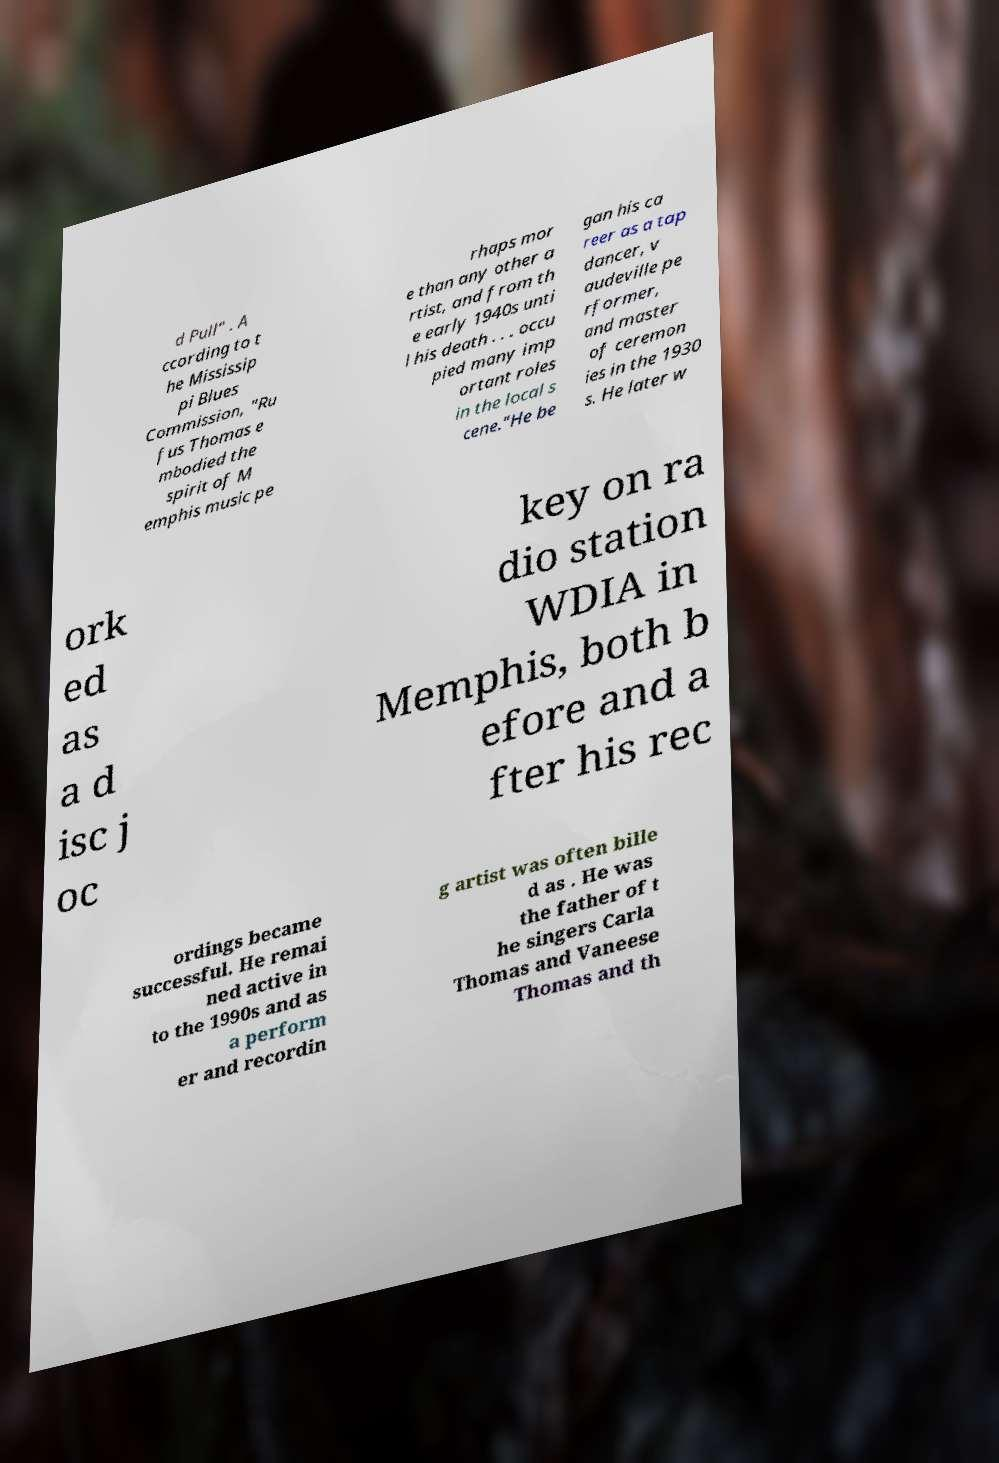For documentation purposes, I need the text within this image transcribed. Could you provide that? d Pull" . A ccording to t he Mississip pi Blues Commission, "Ru fus Thomas e mbodied the spirit of M emphis music pe rhaps mor e than any other a rtist, and from th e early 1940s unti l his death . . . occu pied many imp ortant roles in the local s cene."He be gan his ca reer as a tap dancer, v audeville pe rformer, and master of ceremon ies in the 1930 s. He later w ork ed as a d isc j oc key on ra dio station WDIA in Memphis, both b efore and a fter his rec ordings became successful. He remai ned active in to the 1990s and as a perform er and recordin g artist was often bille d as . He was the father of t he singers Carla Thomas and Vaneese Thomas and th 